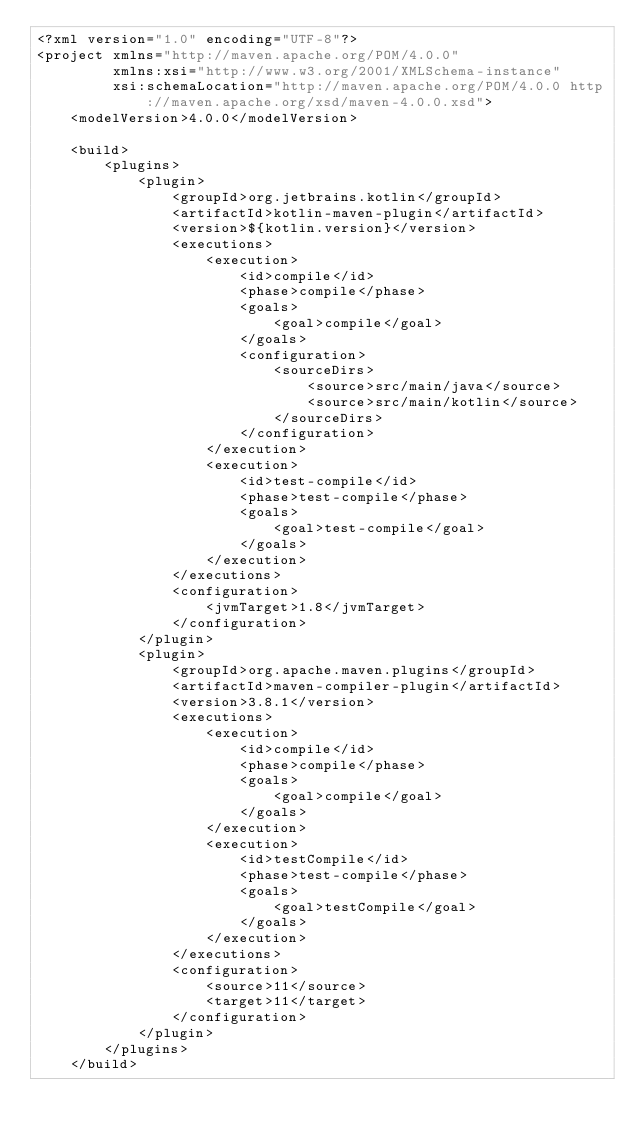<code> <loc_0><loc_0><loc_500><loc_500><_XML_><?xml version="1.0" encoding="UTF-8"?>
<project xmlns="http://maven.apache.org/POM/4.0.0"
         xmlns:xsi="http://www.w3.org/2001/XMLSchema-instance"
         xsi:schemaLocation="http://maven.apache.org/POM/4.0.0 http://maven.apache.org/xsd/maven-4.0.0.xsd">
    <modelVersion>4.0.0</modelVersion>

    <build>
        <plugins>
            <plugin>
                <groupId>org.jetbrains.kotlin</groupId>
                <artifactId>kotlin-maven-plugin</artifactId>
                <version>${kotlin.version}</version>
                <executions>
                    <execution>
                        <id>compile</id>
                        <phase>compile</phase>
                        <goals>
                            <goal>compile</goal>
                        </goals>
                        <configuration>
                            <sourceDirs>
                                <source>src/main/java</source>
                                <source>src/main/kotlin</source>
                            </sourceDirs>
                        </configuration>
                    </execution>
                    <execution>
                        <id>test-compile</id>
                        <phase>test-compile</phase>
                        <goals>
                            <goal>test-compile</goal>
                        </goals>
                    </execution>
                </executions>
                <configuration>
                    <jvmTarget>1.8</jvmTarget>
                </configuration>
            </plugin>
            <plugin>
                <groupId>org.apache.maven.plugins</groupId>
                <artifactId>maven-compiler-plugin</artifactId>
                <version>3.8.1</version>
                <executions>
                    <execution>
                        <id>compile</id>
                        <phase>compile</phase>
                        <goals>
                            <goal>compile</goal>
                        </goals>
                    </execution>
                    <execution>
                        <id>testCompile</id>
                        <phase>test-compile</phase>
                        <goals>
                            <goal>testCompile</goal>
                        </goals>
                    </execution>
                </executions>
                <configuration>
                    <source>11</source>
                    <target>11</target>
                </configuration>
            </plugin>
        </plugins>
    </build></code> 